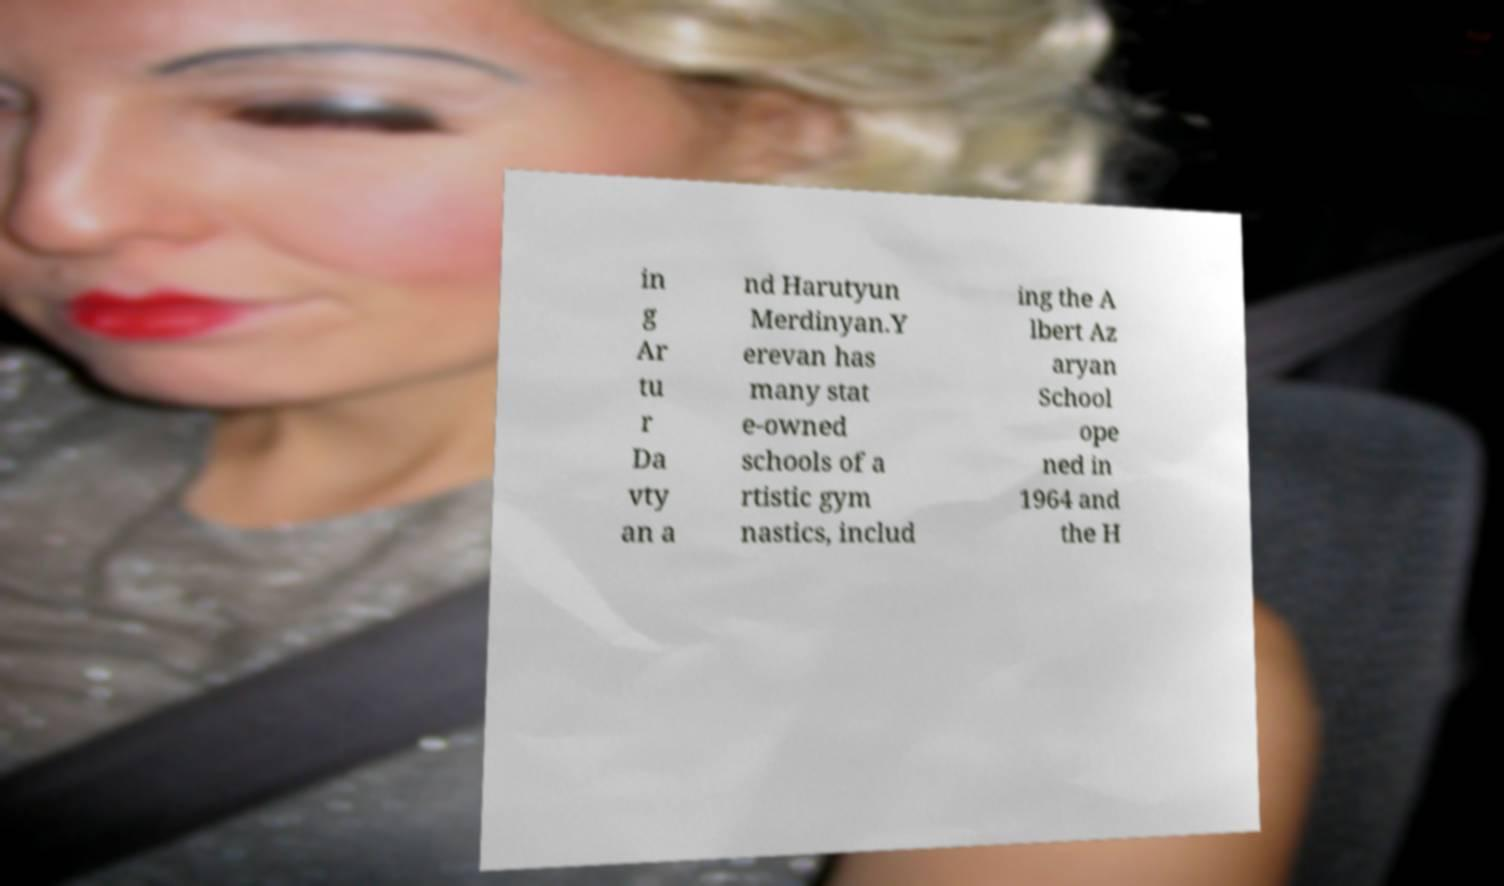Please read and relay the text visible in this image. What does it say? in g Ar tu r Da vty an a nd Harutyun Merdinyan.Y erevan has many stat e-owned schools of a rtistic gym nastics, includ ing the A lbert Az aryan School ope ned in 1964 and the H 